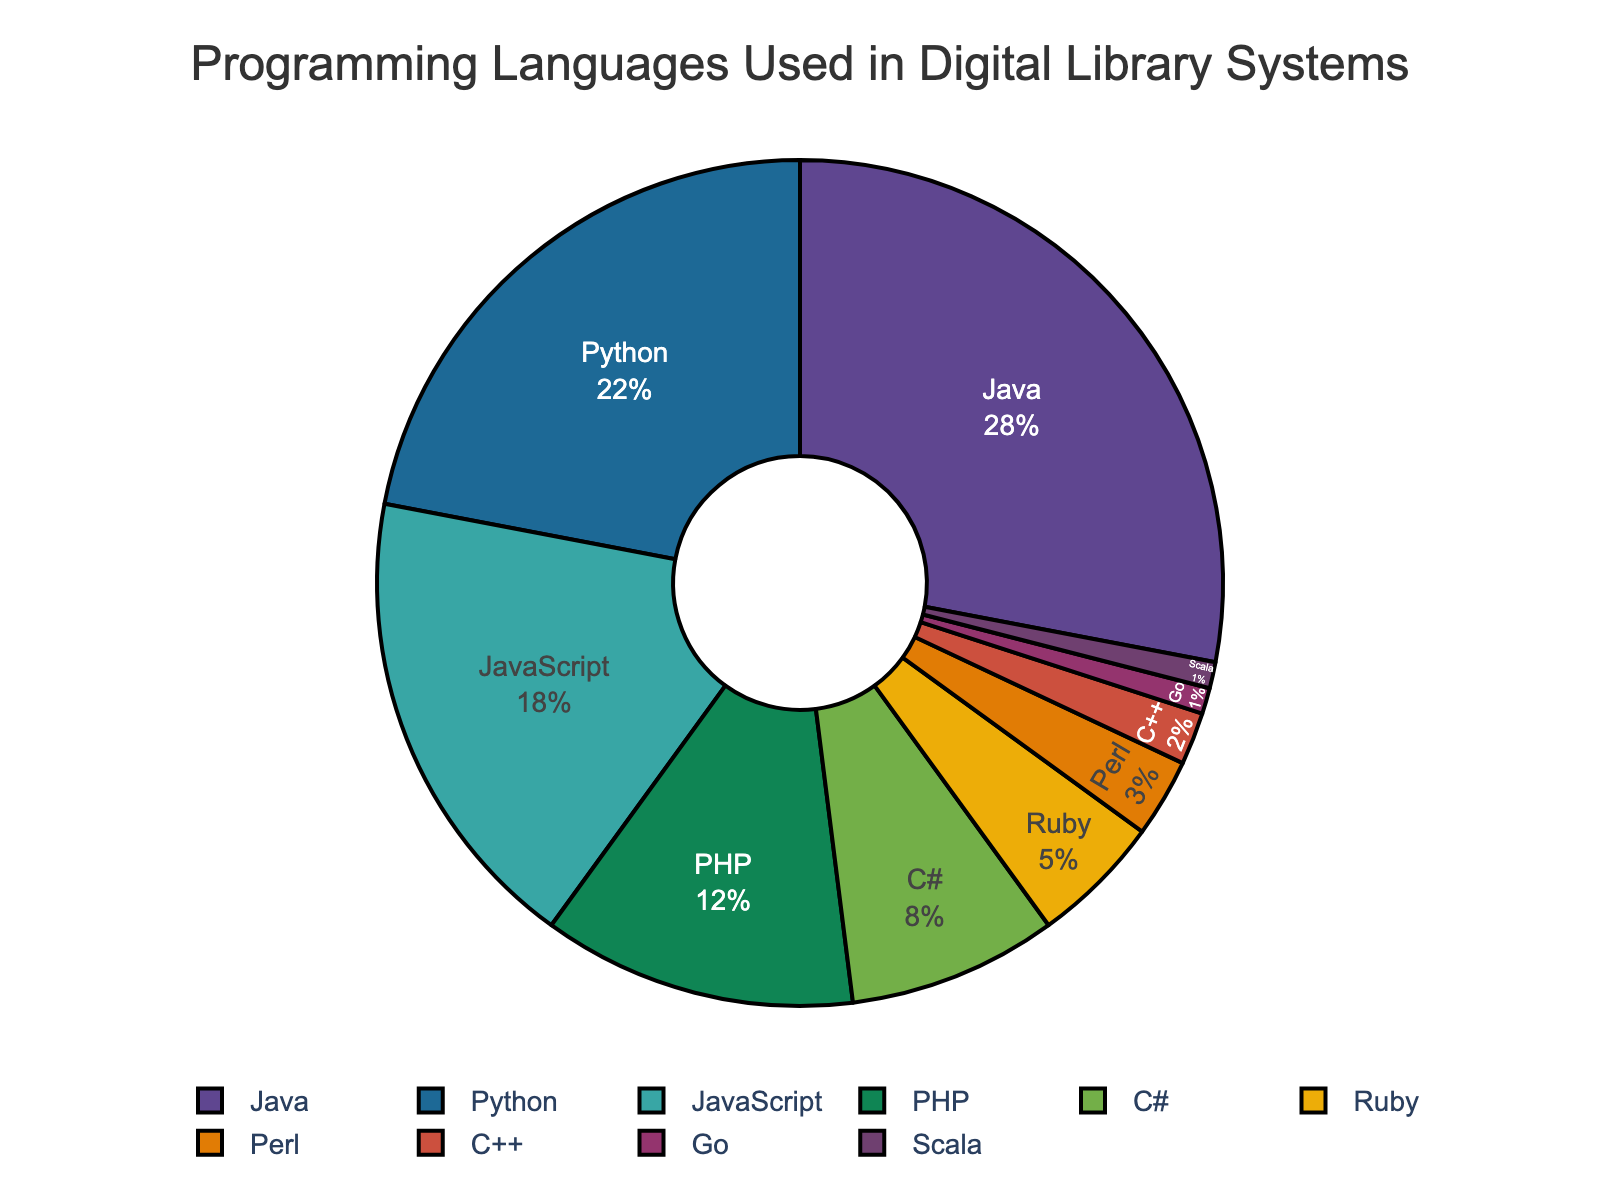What percentage of digital library systems use JavaScript and PHP combined? JavaScript makes up 18% and PHP makes up 12%. Adding these together: 18 + 12 = 30
Answer: 30 Which is used more often in digital library systems, Ruby or C++? Ruby is used in 5% of systems, while C++ is used in 2%. Since 5% is greater than 2%, Ruby is used more often than C++.
Answer: Ruby What is the combined percentage of languages that make up less than 5% each? Perl, C++, Go, and Scala each make up less than 5%. Summing their percentages: 3 + 2 + 1 + 1 = 7
Answer: 7 If you combine the usage of Java and Python, what is their total share of the pie chart? Java is 28% and Python is 22%. Adding these values gives 28 + 22 = 50
Answer: 50 Which language holds the largest share in digital library systems? The largest percentage in the pie chart is 28%, which corresponds to Java.
Answer: Java Which is less popular, Go or Scala? Both Go and Scala have a small share of 1% each. Since they are equal, neither is less popular than the other.
Answer: Neither How much more popular is Python than PHP in digital library systems? Python is at 22% and PHP at 12%. The difference is 22 - 12 = 10
Answer: 10 Are there more systems using C# or Perl? C# is used in 8% of systems while Perl is used in 3%. Since 8% is greater than 3%, more systems use C#.
Answer: C# What percentage of systems use non-scripting languages (Java, C#, C++, Scala)? The percentages for these non-scripting languages are: Java (28%), C# (8%), C++ (2%), Scala (1%). Summing these: 28 + 8 + 2 + 1 = 39
Answer: 39 What is the average percentage for the top three languages? The top three languages by percentage are Java (28%), Python (22%), and JavaScript (18%). The average is (28 + 22 + 18) / 3 = 68 / 3 ≈ 22.67
Answer: 22.67 